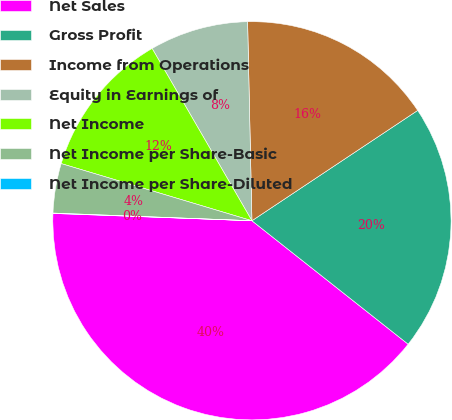Convert chart. <chart><loc_0><loc_0><loc_500><loc_500><pie_chart><fcel>Net Sales<fcel>Gross Profit<fcel>Income from Operations<fcel>Equity in Earnings of<fcel>Net Income<fcel>Net Income per Share-Basic<fcel>Net Income per Share-Diluted<nl><fcel>39.94%<fcel>19.99%<fcel>16.0%<fcel>8.01%<fcel>12.01%<fcel>4.02%<fcel>0.03%<nl></chart> 